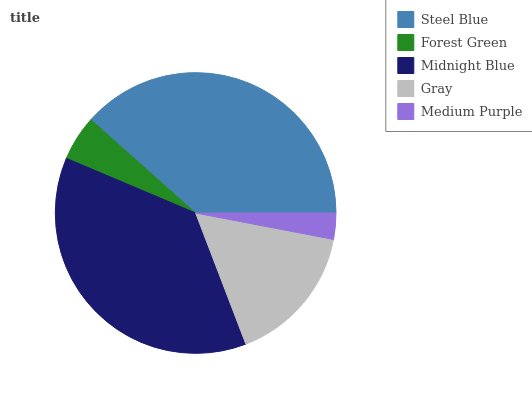Is Medium Purple the minimum?
Answer yes or no. Yes. Is Steel Blue the maximum?
Answer yes or no. Yes. Is Forest Green the minimum?
Answer yes or no. No. Is Forest Green the maximum?
Answer yes or no. No. Is Steel Blue greater than Forest Green?
Answer yes or no. Yes. Is Forest Green less than Steel Blue?
Answer yes or no. Yes. Is Forest Green greater than Steel Blue?
Answer yes or no. No. Is Steel Blue less than Forest Green?
Answer yes or no. No. Is Gray the high median?
Answer yes or no. Yes. Is Gray the low median?
Answer yes or no. Yes. Is Medium Purple the high median?
Answer yes or no. No. Is Steel Blue the low median?
Answer yes or no. No. 